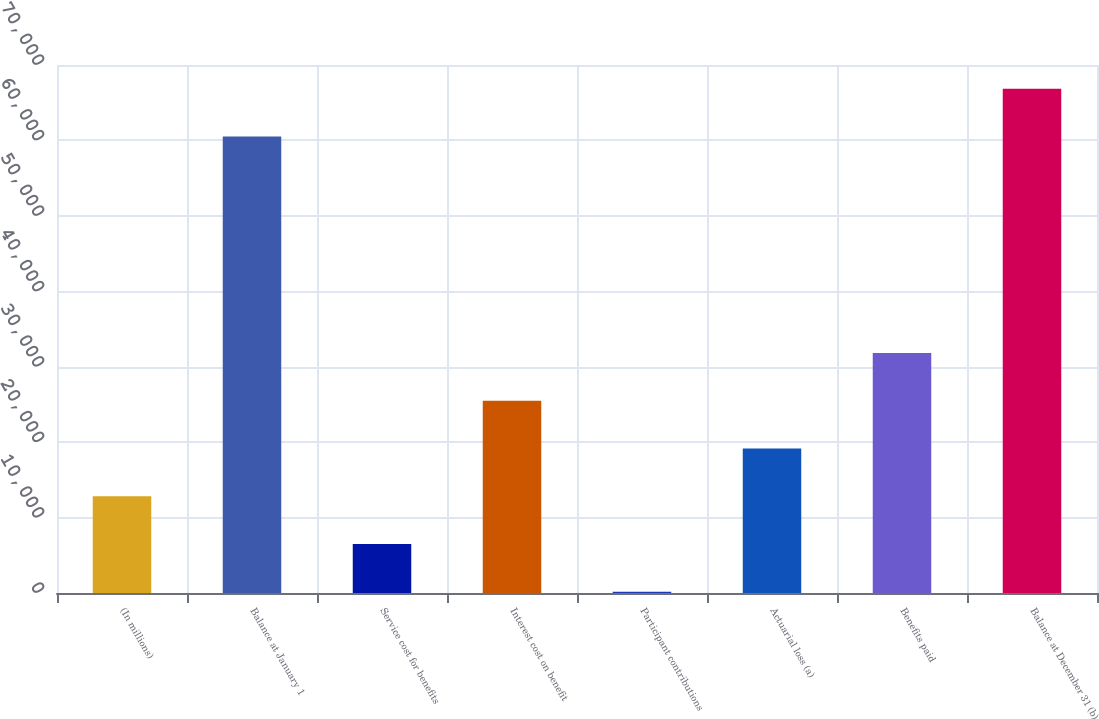<chart> <loc_0><loc_0><loc_500><loc_500><bar_chart><fcel>(In millions)<fcel>Balance at January 1<fcel>Service cost for benefits<fcel>Interest cost on benefit<fcel>Participant contributions<fcel>Actuarial loss (a)<fcel>Benefits paid<fcel>Balance at December 31 (b)<nl><fcel>12826<fcel>60510<fcel>6491.5<fcel>25495<fcel>157<fcel>19160.5<fcel>31829.5<fcel>66844.5<nl></chart> 